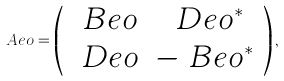Convert formula to latex. <formula><loc_0><loc_0><loc_500><loc_500>\ A e o = \left ( \begin{array} { c c } \ B e o & \ D e o ^ { * } \\ \ D e o & - \ B e o ^ { * } \end{array} \right ) ,</formula> 